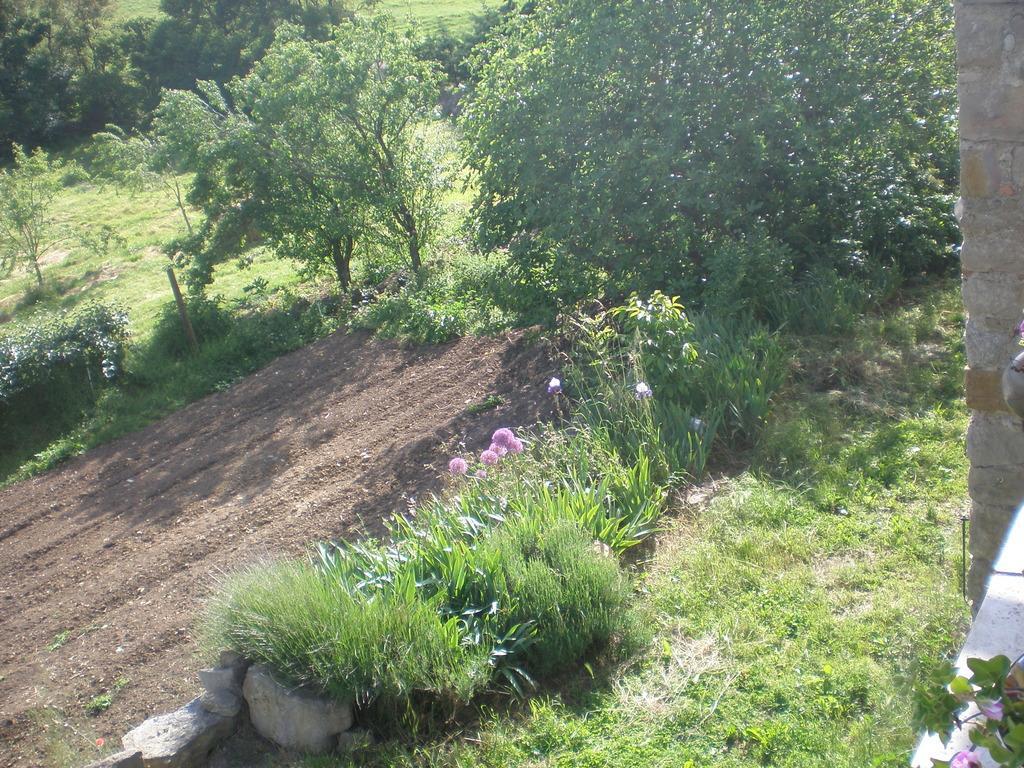Can you describe this image briefly? In the center of the image there are trees. At the bottom there is grass and we can see flowers. 